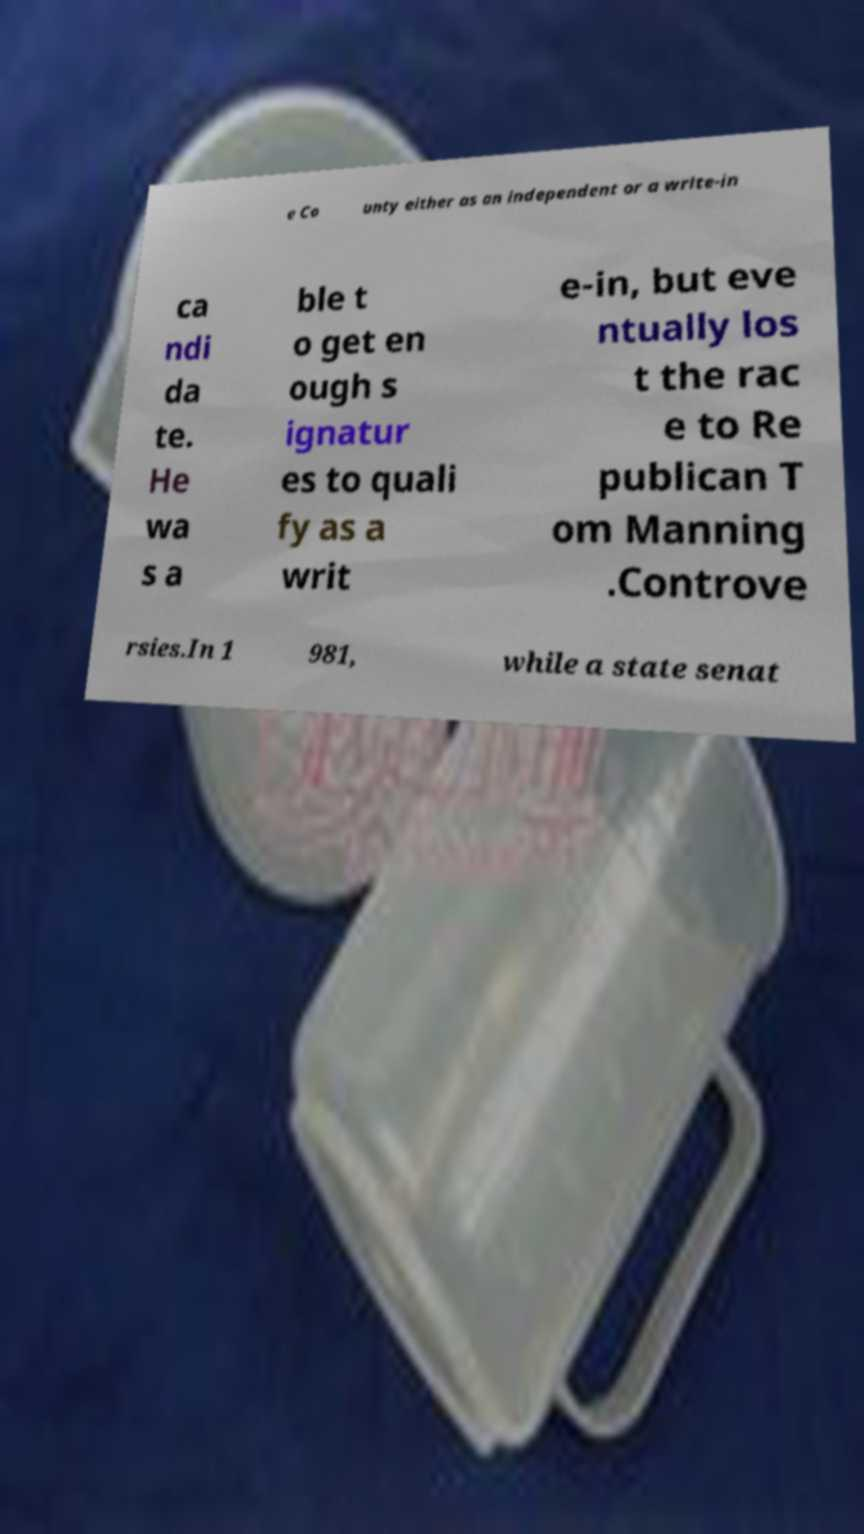Can you accurately transcribe the text from the provided image for me? e Co unty either as an independent or a write-in ca ndi da te. He wa s a ble t o get en ough s ignatur es to quali fy as a writ e-in, but eve ntually los t the rac e to Re publican T om Manning .Controve rsies.In 1 981, while a state senat 